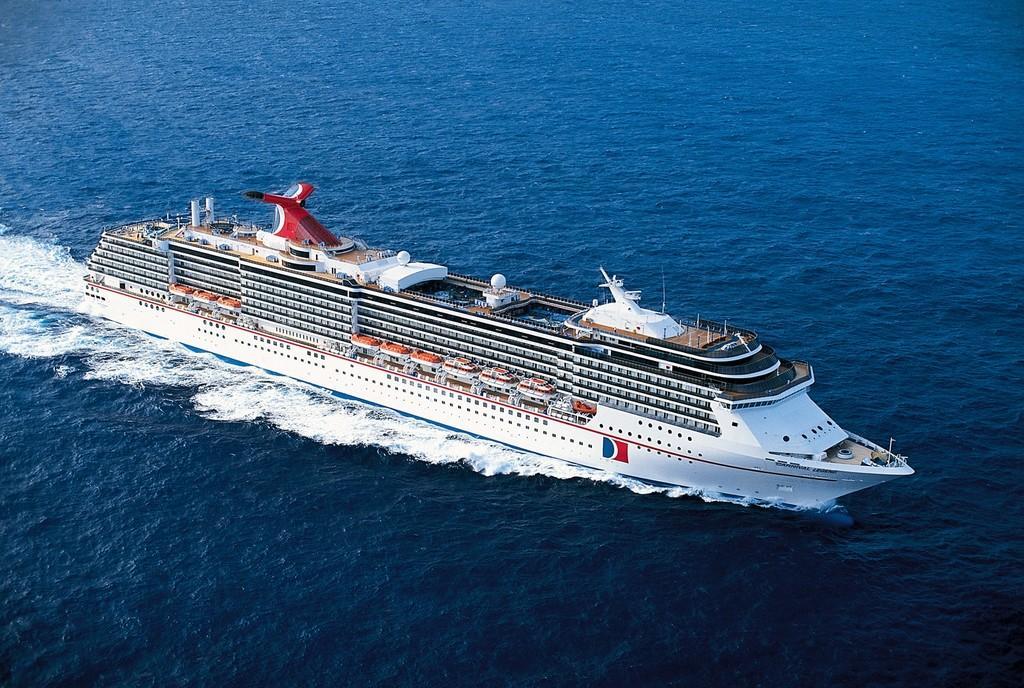Please provide a concise description of this image. There is a white cruise on the water. 